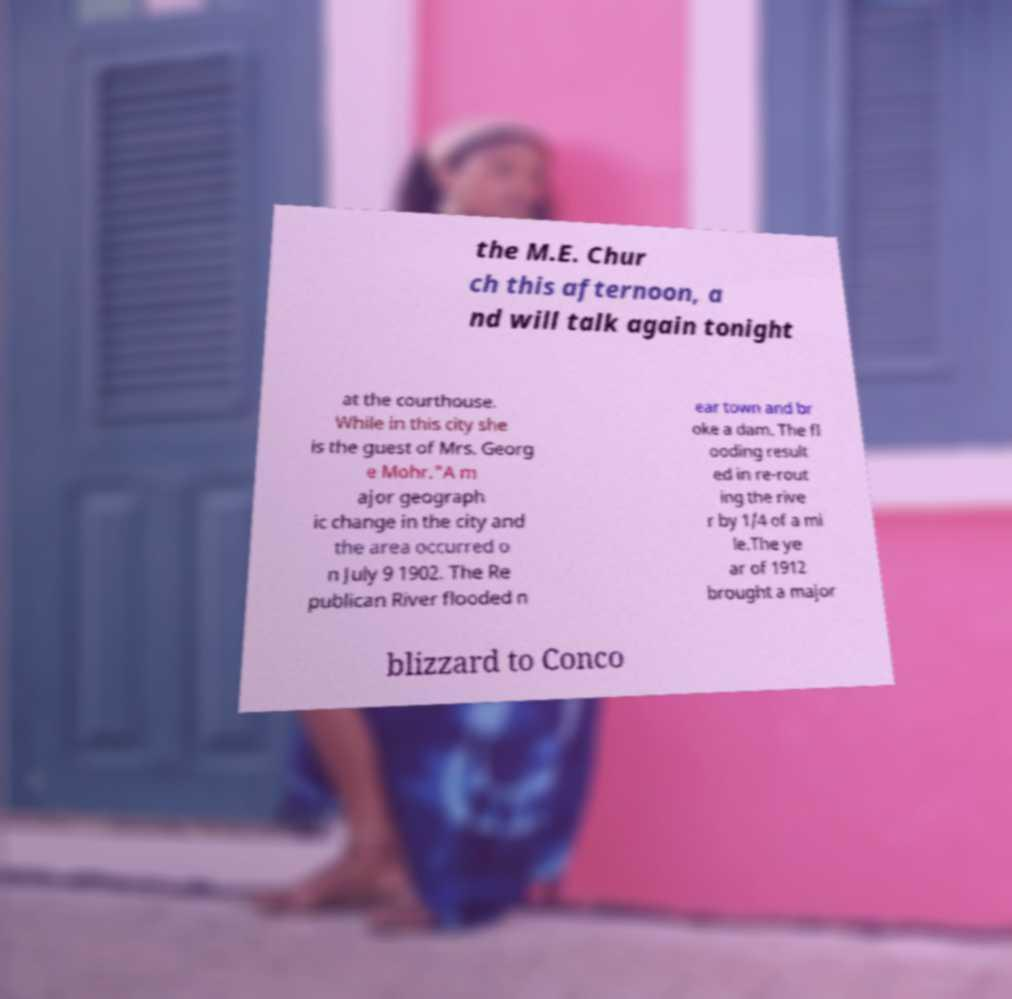For documentation purposes, I need the text within this image transcribed. Could you provide that? the M.E. Chur ch this afternoon, a nd will talk again tonight at the courthouse. While in this city she is the guest of Mrs. Georg e Mohr."A m ajor geograph ic change in the city and the area occurred o n July 9 1902. The Re publican River flooded n ear town and br oke a dam. The fl ooding result ed in re-rout ing the rive r by 1/4 of a mi le.The ye ar of 1912 brought a major blizzard to Conco 